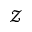<formula> <loc_0><loc_0><loc_500><loc_500>\mathcal { Z }</formula> 